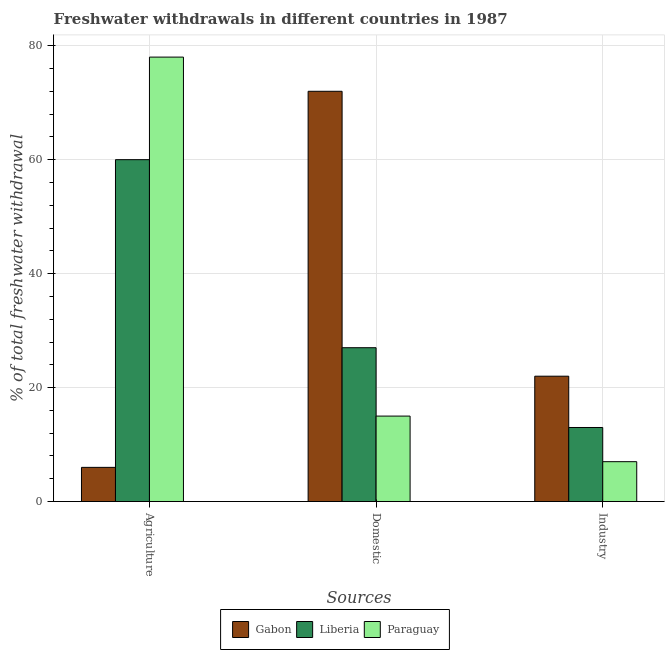Are the number of bars per tick equal to the number of legend labels?
Your response must be concise. Yes. How many bars are there on the 2nd tick from the left?
Offer a terse response. 3. What is the label of the 2nd group of bars from the left?
Offer a terse response. Domestic. Across all countries, what is the maximum percentage of freshwater withdrawal for agriculture?
Ensure brevity in your answer.  78. Across all countries, what is the minimum percentage of freshwater withdrawal for domestic purposes?
Make the answer very short. 15. In which country was the percentage of freshwater withdrawal for industry maximum?
Give a very brief answer. Gabon. In which country was the percentage of freshwater withdrawal for agriculture minimum?
Keep it short and to the point. Gabon. What is the total percentage of freshwater withdrawal for domestic purposes in the graph?
Your response must be concise. 114. What is the difference between the percentage of freshwater withdrawal for agriculture in Gabon and that in Liberia?
Provide a short and direct response. -54. What is the difference between the percentage of freshwater withdrawal for domestic purposes in Paraguay and the percentage of freshwater withdrawal for agriculture in Liberia?
Make the answer very short. -45. What is the difference between the percentage of freshwater withdrawal for domestic purposes and percentage of freshwater withdrawal for agriculture in Gabon?
Offer a terse response. 66. What is the ratio of the percentage of freshwater withdrawal for domestic purposes in Gabon to that in Liberia?
Make the answer very short. 2.67. What is the difference between the highest and the lowest percentage of freshwater withdrawal for agriculture?
Your answer should be compact. 72. Is the sum of the percentage of freshwater withdrawal for industry in Paraguay and Liberia greater than the maximum percentage of freshwater withdrawal for agriculture across all countries?
Make the answer very short. No. What does the 2nd bar from the left in Domestic represents?
Offer a very short reply. Liberia. What does the 2nd bar from the right in Industry represents?
Give a very brief answer. Liberia. How many bars are there?
Your answer should be compact. 9. Are all the bars in the graph horizontal?
Your answer should be very brief. No. How many countries are there in the graph?
Your answer should be compact. 3. Does the graph contain any zero values?
Ensure brevity in your answer.  No. Does the graph contain grids?
Give a very brief answer. Yes. Where does the legend appear in the graph?
Provide a succinct answer. Bottom center. How many legend labels are there?
Provide a short and direct response. 3. How are the legend labels stacked?
Keep it short and to the point. Horizontal. What is the title of the graph?
Keep it short and to the point. Freshwater withdrawals in different countries in 1987. What is the label or title of the X-axis?
Provide a short and direct response. Sources. What is the label or title of the Y-axis?
Provide a short and direct response. % of total freshwater withdrawal. What is the % of total freshwater withdrawal of Liberia in Agriculture?
Ensure brevity in your answer.  60. What is the % of total freshwater withdrawal of Paraguay in Domestic?
Make the answer very short. 15. What is the % of total freshwater withdrawal of Gabon in Industry?
Provide a short and direct response. 22. What is the % of total freshwater withdrawal in Paraguay in Industry?
Offer a very short reply. 7. Across all Sources, what is the maximum % of total freshwater withdrawal of Gabon?
Your answer should be compact. 72. Across all Sources, what is the maximum % of total freshwater withdrawal of Liberia?
Keep it short and to the point. 60. Across all Sources, what is the maximum % of total freshwater withdrawal in Paraguay?
Provide a short and direct response. 78. Across all Sources, what is the minimum % of total freshwater withdrawal of Gabon?
Provide a short and direct response. 6. Across all Sources, what is the minimum % of total freshwater withdrawal in Paraguay?
Offer a very short reply. 7. What is the total % of total freshwater withdrawal in Paraguay in the graph?
Ensure brevity in your answer.  100. What is the difference between the % of total freshwater withdrawal of Gabon in Agriculture and that in Domestic?
Your response must be concise. -66. What is the difference between the % of total freshwater withdrawal in Liberia in Agriculture and that in Domestic?
Provide a short and direct response. 33. What is the difference between the % of total freshwater withdrawal of Paraguay in Agriculture and that in Domestic?
Provide a short and direct response. 63. What is the difference between the % of total freshwater withdrawal in Gabon in Agriculture and that in Industry?
Your answer should be very brief. -16. What is the difference between the % of total freshwater withdrawal in Paraguay in Agriculture and that in Industry?
Your answer should be very brief. 71. What is the difference between the % of total freshwater withdrawal in Liberia in Domestic and that in Industry?
Provide a succinct answer. 14. What is the difference between the % of total freshwater withdrawal in Paraguay in Domestic and that in Industry?
Your answer should be very brief. 8. What is the difference between the % of total freshwater withdrawal in Gabon in Agriculture and the % of total freshwater withdrawal in Liberia in Domestic?
Provide a short and direct response. -21. What is the difference between the % of total freshwater withdrawal of Gabon in Agriculture and the % of total freshwater withdrawal of Liberia in Industry?
Your answer should be compact. -7. What is the difference between the % of total freshwater withdrawal in Gabon in Agriculture and the % of total freshwater withdrawal in Paraguay in Industry?
Your answer should be very brief. -1. What is the difference between the % of total freshwater withdrawal in Liberia in Agriculture and the % of total freshwater withdrawal in Paraguay in Industry?
Offer a very short reply. 53. What is the average % of total freshwater withdrawal in Gabon per Sources?
Your response must be concise. 33.33. What is the average % of total freshwater withdrawal in Liberia per Sources?
Provide a succinct answer. 33.33. What is the average % of total freshwater withdrawal of Paraguay per Sources?
Offer a terse response. 33.33. What is the difference between the % of total freshwater withdrawal of Gabon and % of total freshwater withdrawal of Liberia in Agriculture?
Provide a short and direct response. -54. What is the difference between the % of total freshwater withdrawal of Gabon and % of total freshwater withdrawal of Paraguay in Agriculture?
Your response must be concise. -72. What is the difference between the % of total freshwater withdrawal in Gabon and % of total freshwater withdrawal in Paraguay in Domestic?
Give a very brief answer. 57. What is the difference between the % of total freshwater withdrawal of Gabon and % of total freshwater withdrawal of Paraguay in Industry?
Give a very brief answer. 15. What is the ratio of the % of total freshwater withdrawal in Gabon in Agriculture to that in Domestic?
Offer a terse response. 0.08. What is the ratio of the % of total freshwater withdrawal in Liberia in Agriculture to that in Domestic?
Ensure brevity in your answer.  2.22. What is the ratio of the % of total freshwater withdrawal in Paraguay in Agriculture to that in Domestic?
Your response must be concise. 5.2. What is the ratio of the % of total freshwater withdrawal of Gabon in Agriculture to that in Industry?
Your response must be concise. 0.27. What is the ratio of the % of total freshwater withdrawal of Liberia in Agriculture to that in Industry?
Offer a very short reply. 4.62. What is the ratio of the % of total freshwater withdrawal in Paraguay in Agriculture to that in Industry?
Provide a succinct answer. 11.14. What is the ratio of the % of total freshwater withdrawal of Gabon in Domestic to that in Industry?
Offer a very short reply. 3.27. What is the ratio of the % of total freshwater withdrawal in Liberia in Domestic to that in Industry?
Give a very brief answer. 2.08. What is the ratio of the % of total freshwater withdrawal in Paraguay in Domestic to that in Industry?
Provide a short and direct response. 2.14. What is the difference between the highest and the second highest % of total freshwater withdrawal of Gabon?
Offer a terse response. 50. What is the difference between the highest and the second highest % of total freshwater withdrawal in Liberia?
Your answer should be compact. 33. What is the difference between the highest and the second highest % of total freshwater withdrawal in Paraguay?
Give a very brief answer. 63. What is the difference between the highest and the lowest % of total freshwater withdrawal in Gabon?
Your response must be concise. 66. What is the difference between the highest and the lowest % of total freshwater withdrawal of Liberia?
Ensure brevity in your answer.  47. 